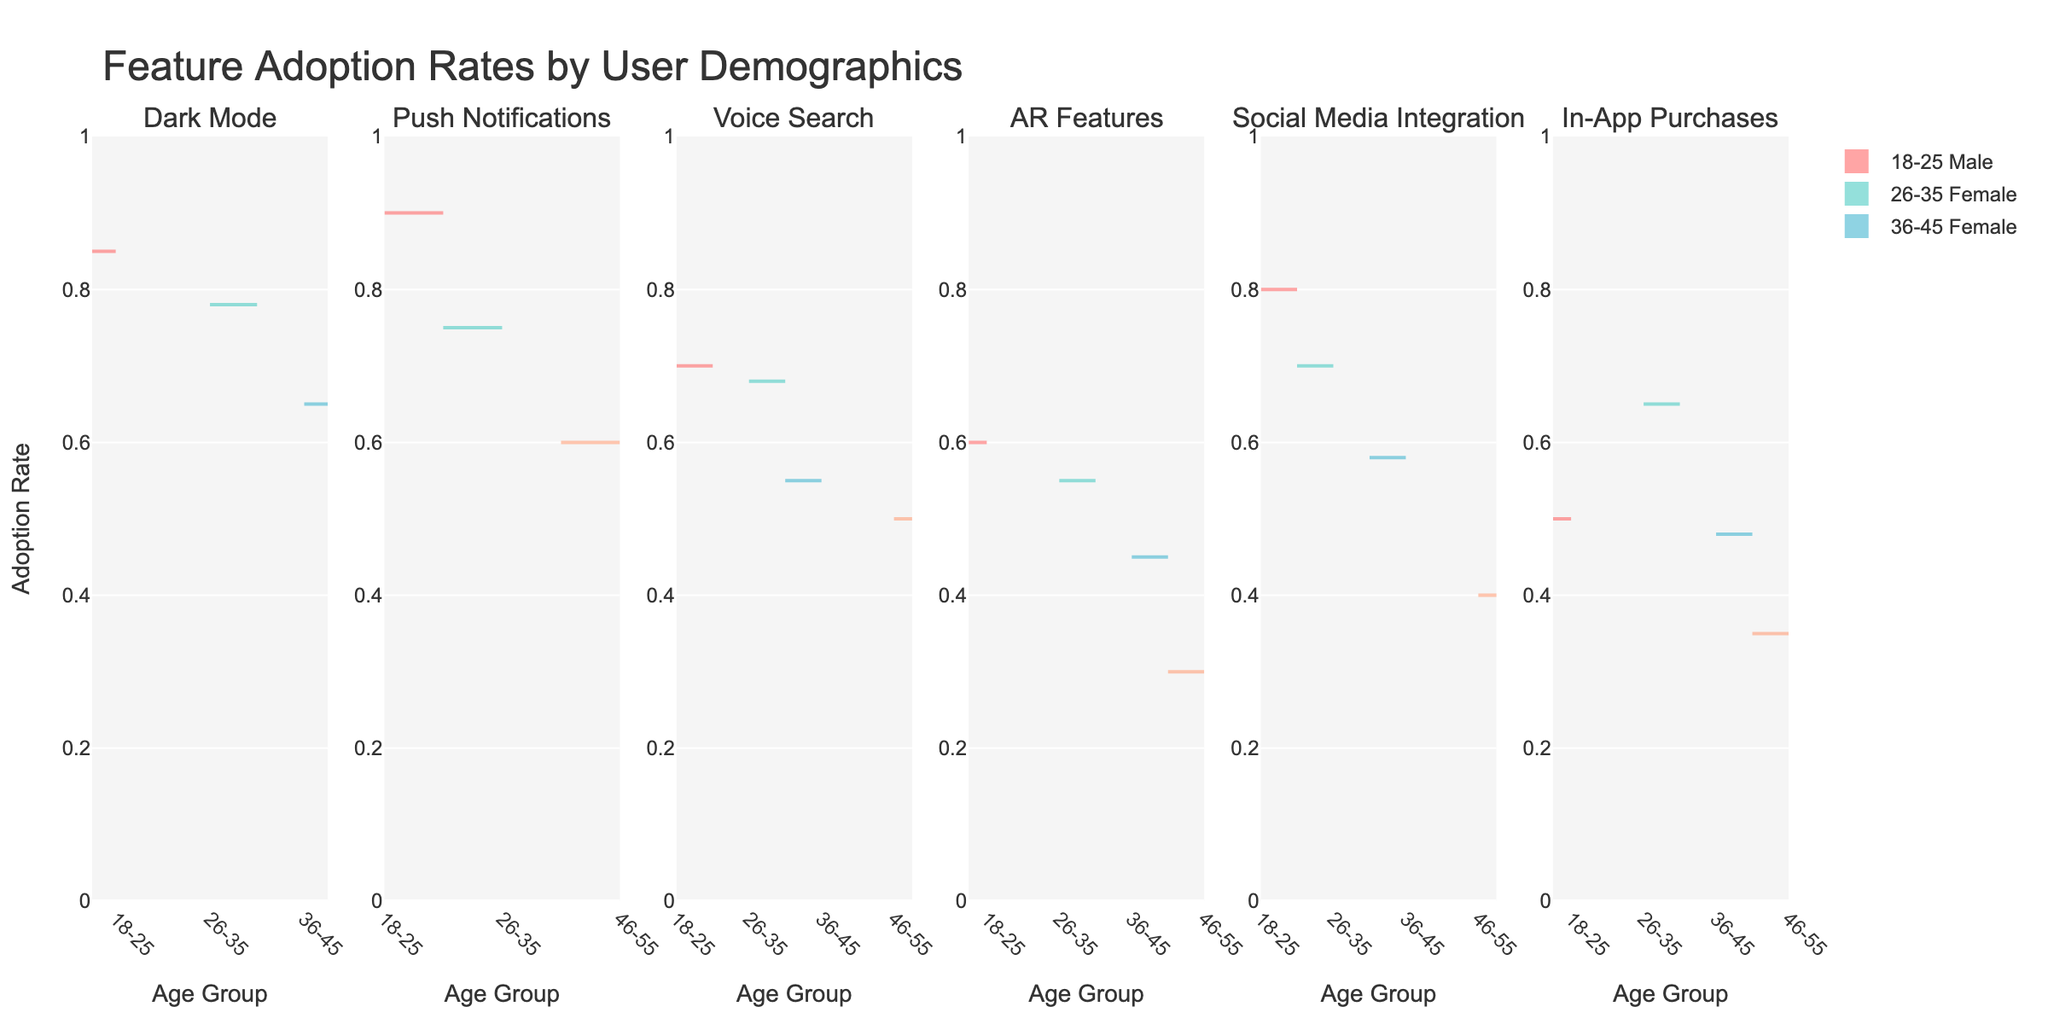Which feature has the highest adoption rate for males aged 18-25? To determine this, we look at the violin plot for each feature corresponding to the age group 18-25 Male and identify the highest adoption rate.
Answer: Dark Mode What is the overall trend in feature adoption rates among females aged 26-35 compared to females aged 36-45? Compare the median heights of the violin plots for females in age groups 26-35 and 36-45 across all features. For each feature, observe if the 26-35 age group's peak is generally higher, lower, or similar to that of the 36-45 age group.
Answer: Generally higher for 26-35 Which gender has a higher adoption rate for AR Features in the age group 26-35? Look at the violin plot for AR Features and compare the peaks of the male and female subsets within the 26-35 age group.
Answer: Female Compare the range of adoption rates for Push Notifications across different age groups for males. Examine the extent of the violin plots for Push Notifications for males in each age group: 18-25, 26-35, 36-45, and 46-55. Determine the variability by noting the range (minimum to maximum values) in each plot.
Answer: 18-25 has the highest range Which age group has the lowest adoption rate for Social Media Integration among females? Find the violin plot for Social Media Integration and identify the age group with the lowest peak on the positive side of the violin plot for females.
Answer: 46-55 Is there any feature where males aged 46-55 have an adoption rate higher than females of the same age group? Compare the violin plots for each feature in the age group 46-55, and check if there is any instance where the male peak is higher than the female peak.
Answer: No 